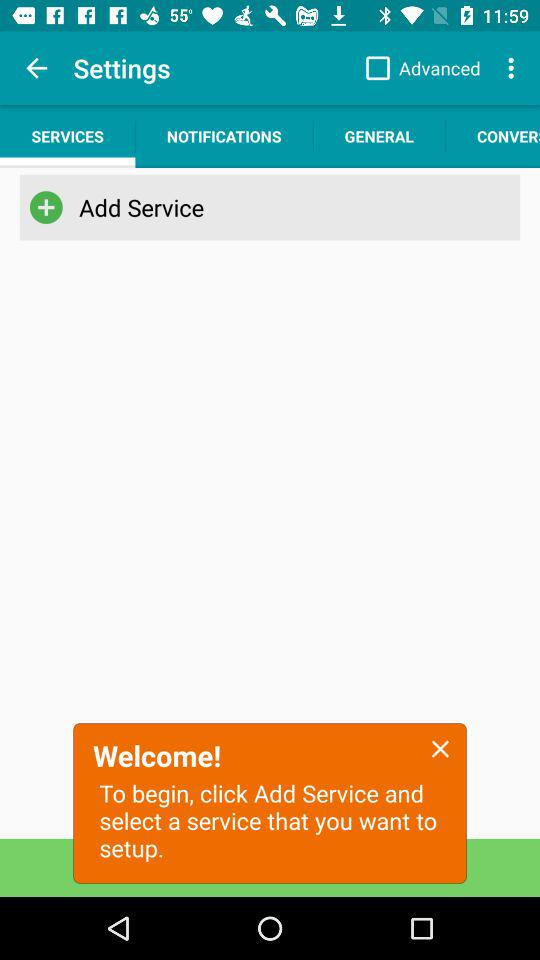What is the selected option? The selected option is "SERVICES". 